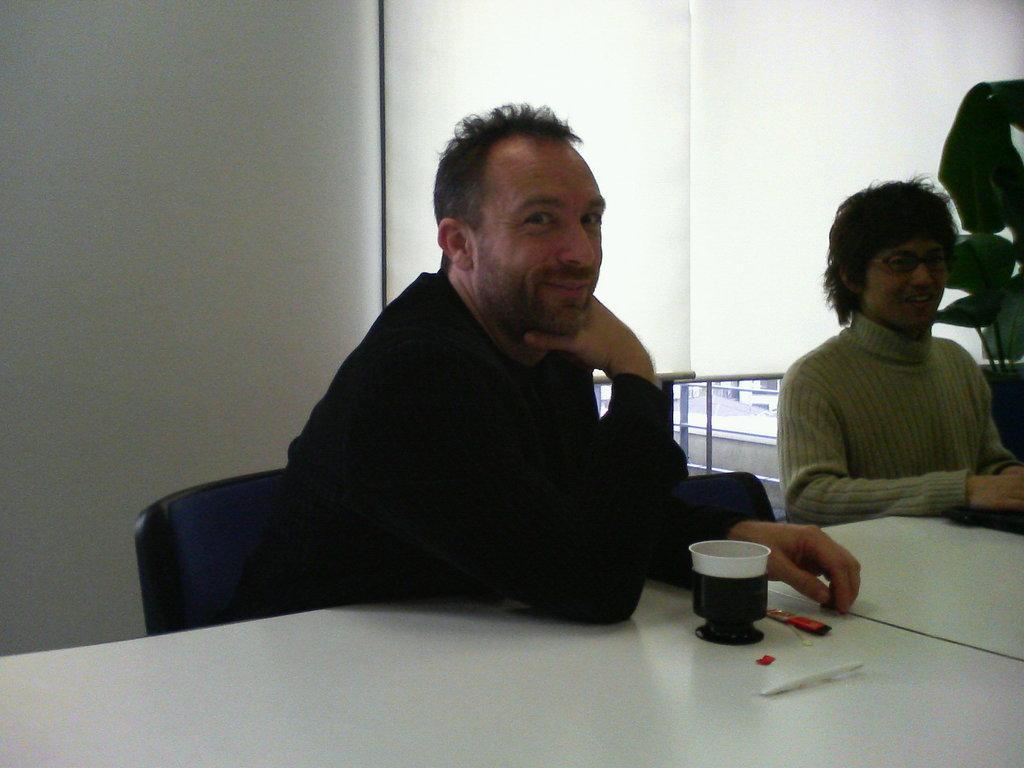Can you describe this image briefly? In this image I can see two persons are sitting on chairs and in the front of them I can see a white colour table. On the table I can see a cup and few other stuffs. In the background I can see a plant and two window covers. 